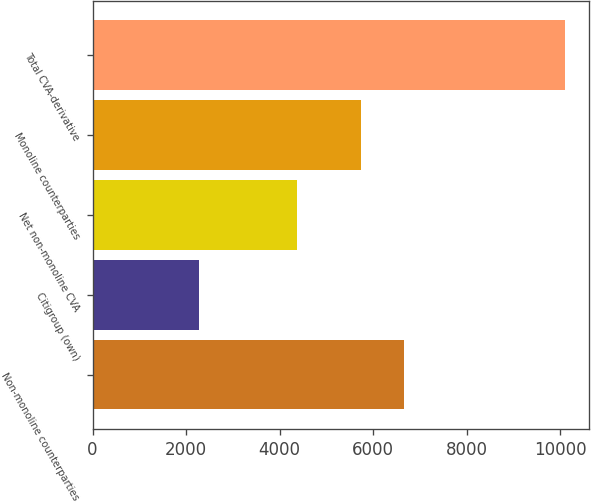Convert chart. <chart><loc_0><loc_0><loc_500><loc_500><bar_chart><fcel>Non-monoline counterparties<fcel>Citigroup (own)<fcel>Net non-monoline CVA<fcel>Monoline counterparties<fcel>Total CVA-derivative<nl><fcel>6653<fcel>2282<fcel>4371<fcel>5736<fcel>10107<nl></chart> 